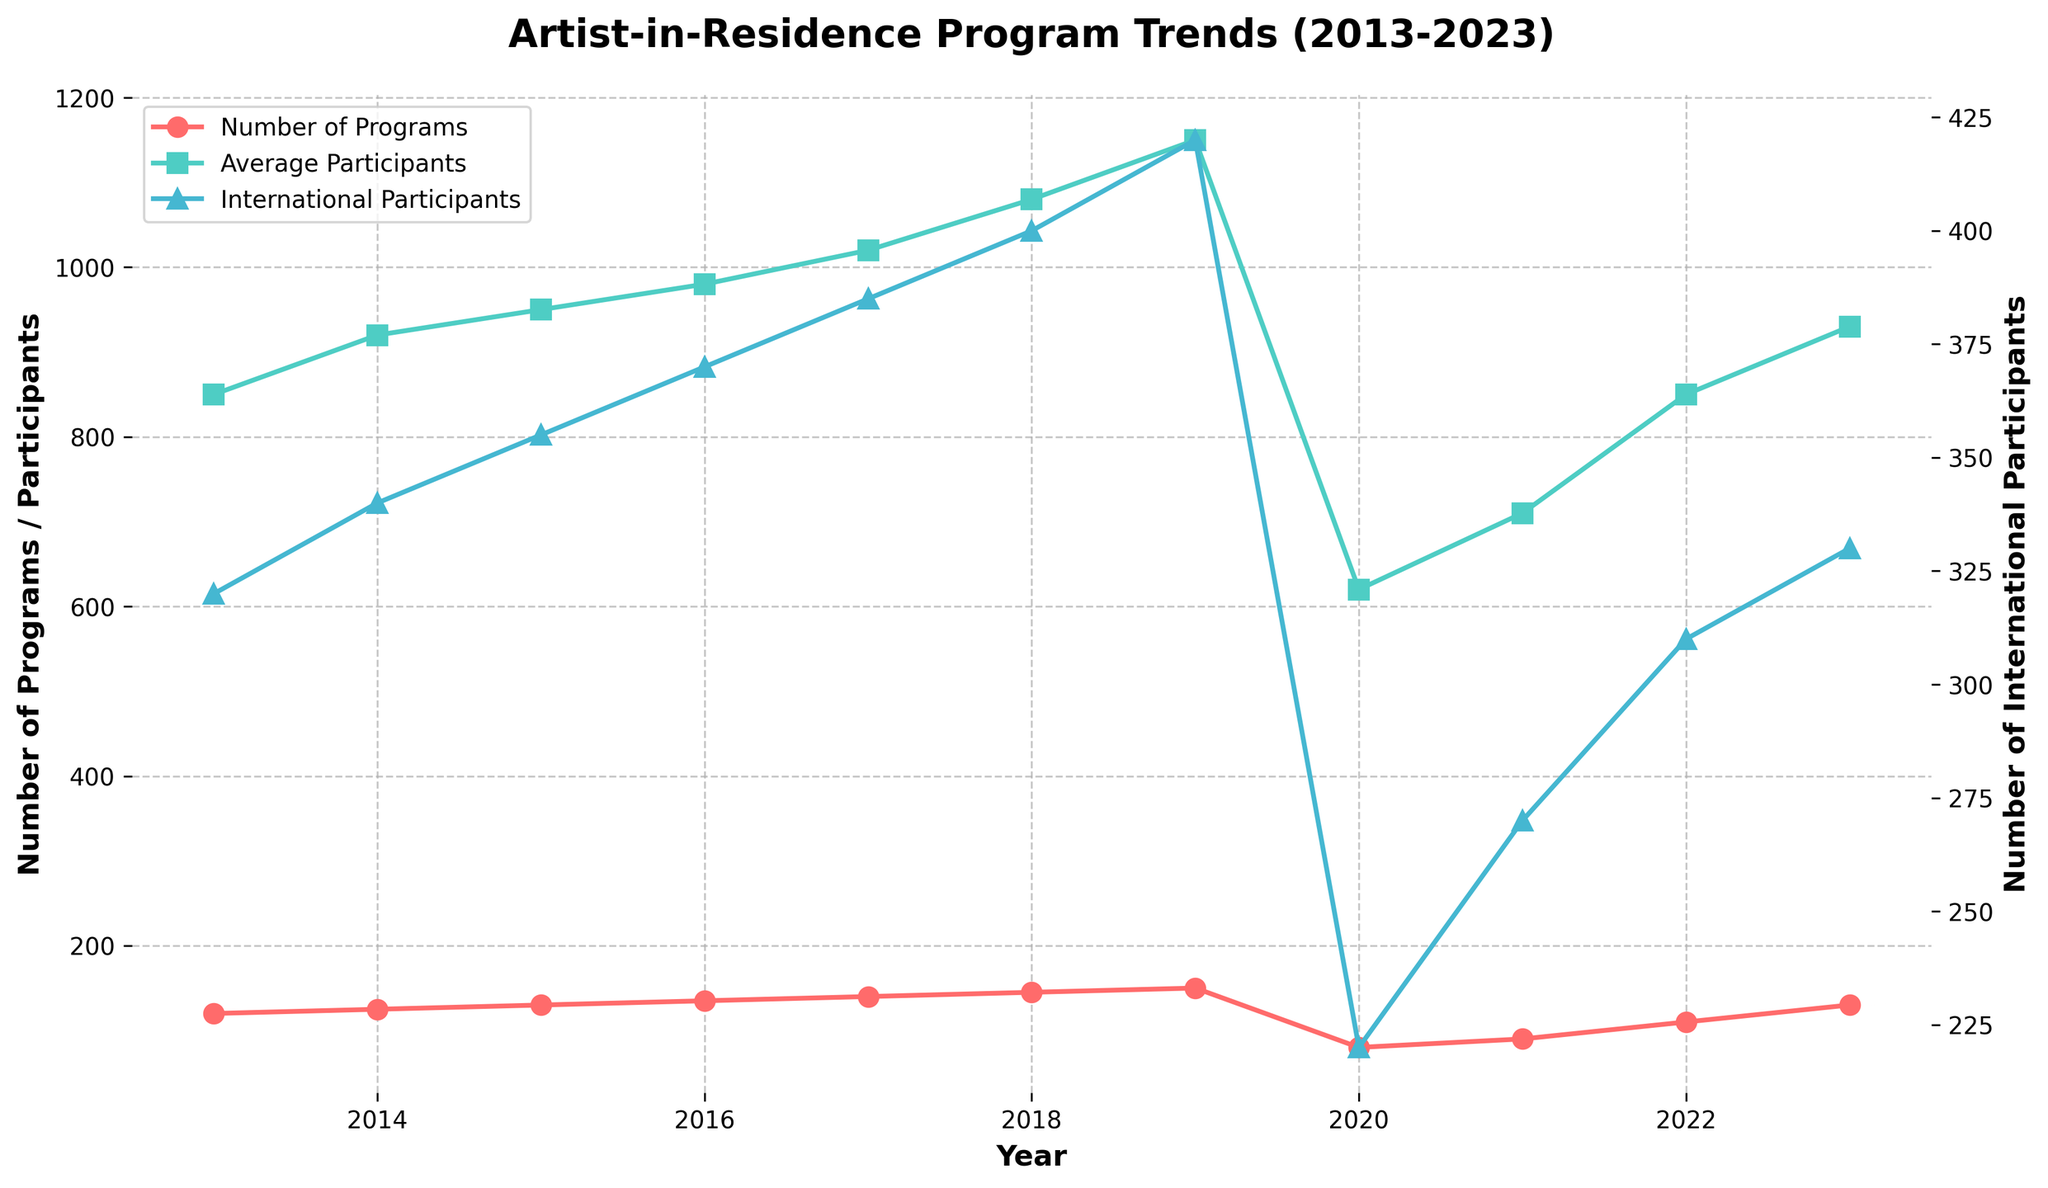How many lines are plotted in the figure? There are three lines plotted in the figure, each representing different data: Number of Programs, Average Participants, and Number of International Participants.
Answer: 3 What annotation is made in the figure? The annotation "COVID-19 Impact" is made in the figure, indicating the sharp drop in the number of programs in the year 2020.
Answer: COVID-19 Impact Which year had the highest number of programs? The line for the Number of Programs reaches its peak in 2019 before dropping sharply in the following year.
Answer: 2019 Compare the number of international participants in 2013 and 2023. Which year had more? By tracing the line for International Participants, it's clear that 2013 had 320 international participants while 2023 had 330. Thus, 2023 had more international participants.
Answer: 2023 What is the average number of participants in the year 2018? The line for Average Participants in the year 2018 shows a value of 1080.
Answer: 1080 How did the number of programs change from 2019 to 2020? The number of programs dropped sharply from 150 in 2019 to 80 in 2020.
Answer: Sharp decrease What were the trends for the number of programs and average participants before 2020? Both the number of programs and average participants showed a consistent increase from 2013 to 2019.
Answer: Increasing Which year saw the largest increase in the number of average participants? From the plotted line for Average Participants, the largest increase appears to be between 2017 (1020) and 2018 (1080), a difference of 60 participants.
Answer: Between 2017 and 2018 How does the trend of international participants compare to the trend of average participants? Both the number of international participants and the number of average participants show a generally increasing trend from 2013 until 2019, with a decline in subsequent years, although the decline in international participants was less severe.
Answer: Generally similar trends What can be inferred about the impact of COVID-19 on artist-in-residence programs? The sharp drop in both the number of programs and average participants in 2020 indicates a significant negative impact, likely due to COVID-19, as highlighted by the annotation.
Answer: Significant negative impact 